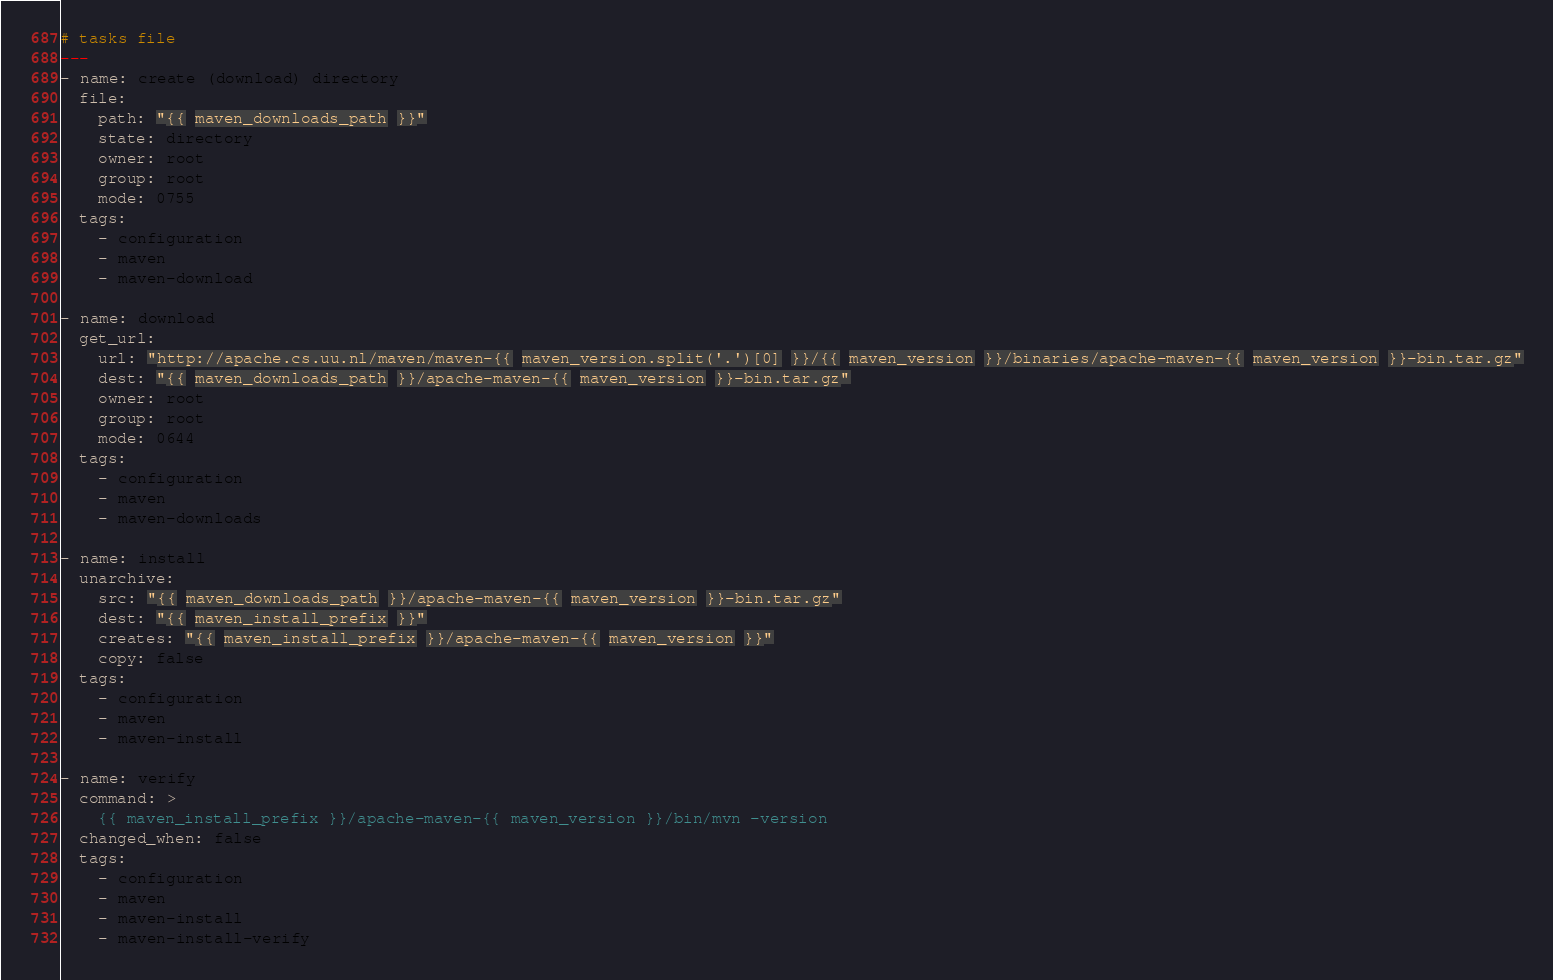Convert code to text. <code><loc_0><loc_0><loc_500><loc_500><_YAML_># tasks file
---
- name: create (download) directory
  file:
    path: "{{ maven_downloads_path }}"
    state: directory
    owner: root
    group: root
    mode: 0755
  tags:
    - configuration
    - maven
    - maven-download

- name: download
  get_url:
    url: "http://apache.cs.uu.nl/maven/maven-{{ maven_version.split('.')[0] }}/{{ maven_version }}/binaries/apache-maven-{{ maven_version }}-bin.tar.gz"
    dest: "{{ maven_downloads_path }}/apache-maven-{{ maven_version }}-bin.tar.gz"
    owner: root
    group: root
    mode: 0644
  tags:
    - configuration
    - maven
    - maven-downloads

- name: install
  unarchive:
    src: "{{ maven_downloads_path }}/apache-maven-{{ maven_version }}-bin.tar.gz"
    dest: "{{ maven_install_prefix }}"
    creates: "{{ maven_install_prefix }}/apache-maven-{{ maven_version }}"
    copy: false
  tags:
    - configuration
    - maven
    - maven-install

- name: verify
  command: >
    {{ maven_install_prefix }}/apache-maven-{{ maven_version }}/bin/mvn -version
  changed_when: false
  tags:
    - configuration
    - maven
    - maven-install
    - maven-install-verify
</code> 